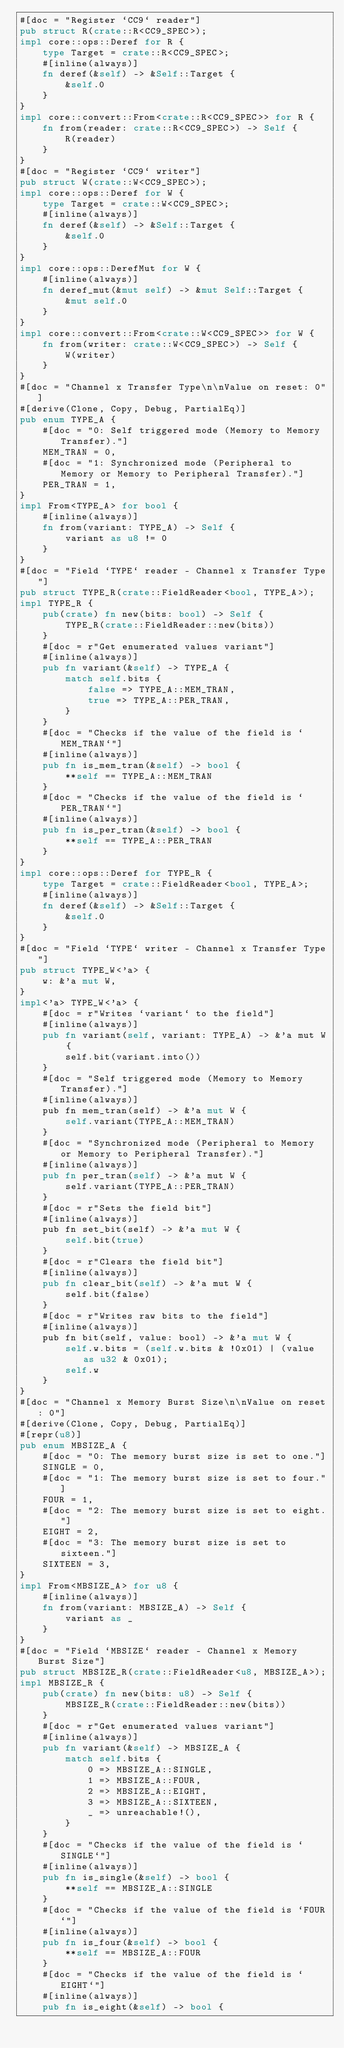<code> <loc_0><loc_0><loc_500><loc_500><_Rust_>#[doc = "Register `CC9` reader"]
pub struct R(crate::R<CC9_SPEC>);
impl core::ops::Deref for R {
    type Target = crate::R<CC9_SPEC>;
    #[inline(always)]
    fn deref(&self) -> &Self::Target {
        &self.0
    }
}
impl core::convert::From<crate::R<CC9_SPEC>> for R {
    fn from(reader: crate::R<CC9_SPEC>) -> Self {
        R(reader)
    }
}
#[doc = "Register `CC9` writer"]
pub struct W(crate::W<CC9_SPEC>);
impl core::ops::Deref for W {
    type Target = crate::W<CC9_SPEC>;
    #[inline(always)]
    fn deref(&self) -> &Self::Target {
        &self.0
    }
}
impl core::ops::DerefMut for W {
    #[inline(always)]
    fn deref_mut(&mut self) -> &mut Self::Target {
        &mut self.0
    }
}
impl core::convert::From<crate::W<CC9_SPEC>> for W {
    fn from(writer: crate::W<CC9_SPEC>) -> Self {
        W(writer)
    }
}
#[doc = "Channel x Transfer Type\n\nValue on reset: 0"]
#[derive(Clone, Copy, Debug, PartialEq)]
pub enum TYPE_A {
    #[doc = "0: Self triggered mode (Memory to Memory Transfer)."]
    MEM_TRAN = 0,
    #[doc = "1: Synchronized mode (Peripheral to Memory or Memory to Peripheral Transfer)."]
    PER_TRAN = 1,
}
impl From<TYPE_A> for bool {
    #[inline(always)]
    fn from(variant: TYPE_A) -> Self {
        variant as u8 != 0
    }
}
#[doc = "Field `TYPE` reader - Channel x Transfer Type"]
pub struct TYPE_R(crate::FieldReader<bool, TYPE_A>);
impl TYPE_R {
    pub(crate) fn new(bits: bool) -> Self {
        TYPE_R(crate::FieldReader::new(bits))
    }
    #[doc = r"Get enumerated values variant"]
    #[inline(always)]
    pub fn variant(&self) -> TYPE_A {
        match self.bits {
            false => TYPE_A::MEM_TRAN,
            true => TYPE_A::PER_TRAN,
        }
    }
    #[doc = "Checks if the value of the field is `MEM_TRAN`"]
    #[inline(always)]
    pub fn is_mem_tran(&self) -> bool {
        **self == TYPE_A::MEM_TRAN
    }
    #[doc = "Checks if the value of the field is `PER_TRAN`"]
    #[inline(always)]
    pub fn is_per_tran(&self) -> bool {
        **self == TYPE_A::PER_TRAN
    }
}
impl core::ops::Deref for TYPE_R {
    type Target = crate::FieldReader<bool, TYPE_A>;
    #[inline(always)]
    fn deref(&self) -> &Self::Target {
        &self.0
    }
}
#[doc = "Field `TYPE` writer - Channel x Transfer Type"]
pub struct TYPE_W<'a> {
    w: &'a mut W,
}
impl<'a> TYPE_W<'a> {
    #[doc = r"Writes `variant` to the field"]
    #[inline(always)]
    pub fn variant(self, variant: TYPE_A) -> &'a mut W {
        self.bit(variant.into())
    }
    #[doc = "Self triggered mode (Memory to Memory Transfer)."]
    #[inline(always)]
    pub fn mem_tran(self) -> &'a mut W {
        self.variant(TYPE_A::MEM_TRAN)
    }
    #[doc = "Synchronized mode (Peripheral to Memory or Memory to Peripheral Transfer)."]
    #[inline(always)]
    pub fn per_tran(self) -> &'a mut W {
        self.variant(TYPE_A::PER_TRAN)
    }
    #[doc = r"Sets the field bit"]
    #[inline(always)]
    pub fn set_bit(self) -> &'a mut W {
        self.bit(true)
    }
    #[doc = r"Clears the field bit"]
    #[inline(always)]
    pub fn clear_bit(self) -> &'a mut W {
        self.bit(false)
    }
    #[doc = r"Writes raw bits to the field"]
    #[inline(always)]
    pub fn bit(self, value: bool) -> &'a mut W {
        self.w.bits = (self.w.bits & !0x01) | (value as u32 & 0x01);
        self.w
    }
}
#[doc = "Channel x Memory Burst Size\n\nValue on reset: 0"]
#[derive(Clone, Copy, Debug, PartialEq)]
#[repr(u8)]
pub enum MBSIZE_A {
    #[doc = "0: The memory burst size is set to one."]
    SINGLE = 0,
    #[doc = "1: The memory burst size is set to four."]
    FOUR = 1,
    #[doc = "2: The memory burst size is set to eight."]
    EIGHT = 2,
    #[doc = "3: The memory burst size is set to sixteen."]
    SIXTEEN = 3,
}
impl From<MBSIZE_A> for u8 {
    #[inline(always)]
    fn from(variant: MBSIZE_A) -> Self {
        variant as _
    }
}
#[doc = "Field `MBSIZE` reader - Channel x Memory Burst Size"]
pub struct MBSIZE_R(crate::FieldReader<u8, MBSIZE_A>);
impl MBSIZE_R {
    pub(crate) fn new(bits: u8) -> Self {
        MBSIZE_R(crate::FieldReader::new(bits))
    }
    #[doc = r"Get enumerated values variant"]
    #[inline(always)]
    pub fn variant(&self) -> MBSIZE_A {
        match self.bits {
            0 => MBSIZE_A::SINGLE,
            1 => MBSIZE_A::FOUR,
            2 => MBSIZE_A::EIGHT,
            3 => MBSIZE_A::SIXTEEN,
            _ => unreachable!(),
        }
    }
    #[doc = "Checks if the value of the field is `SINGLE`"]
    #[inline(always)]
    pub fn is_single(&self) -> bool {
        **self == MBSIZE_A::SINGLE
    }
    #[doc = "Checks if the value of the field is `FOUR`"]
    #[inline(always)]
    pub fn is_four(&self) -> bool {
        **self == MBSIZE_A::FOUR
    }
    #[doc = "Checks if the value of the field is `EIGHT`"]
    #[inline(always)]
    pub fn is_eight(&self) -> bool {</code> 